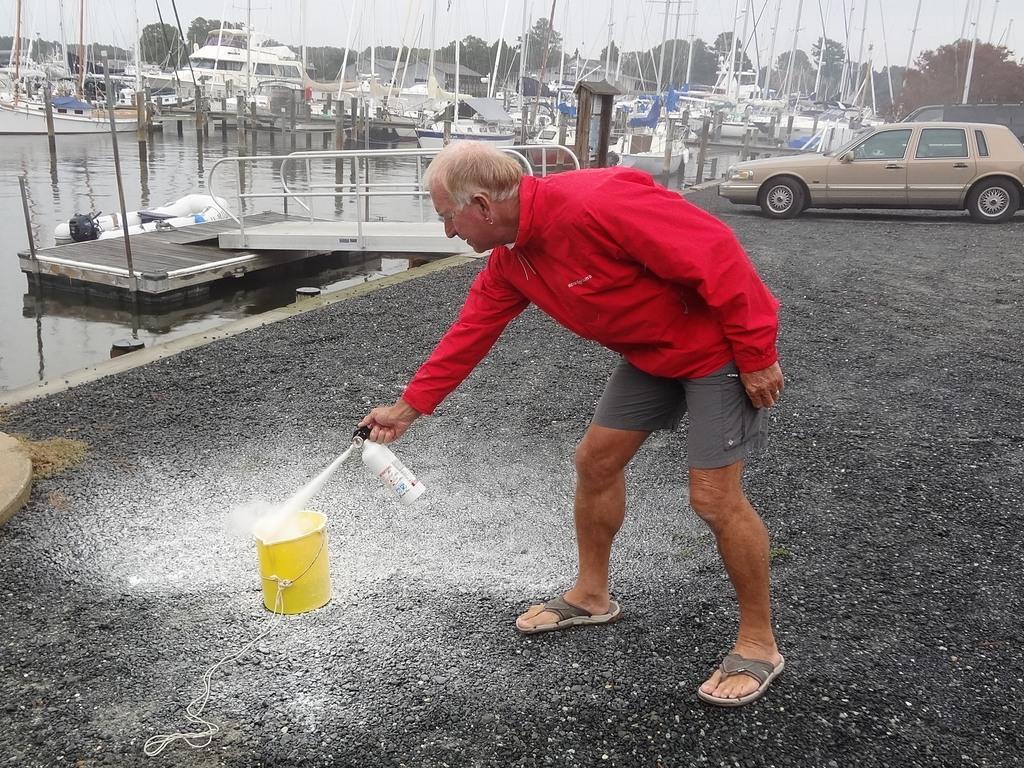Describe this image in one or two sentences. In this image I can see a person wearing red colored jacket is standing and holding an object in his hand. I can see few vehicles, the water, few boats, few trees and the sky in the background. 